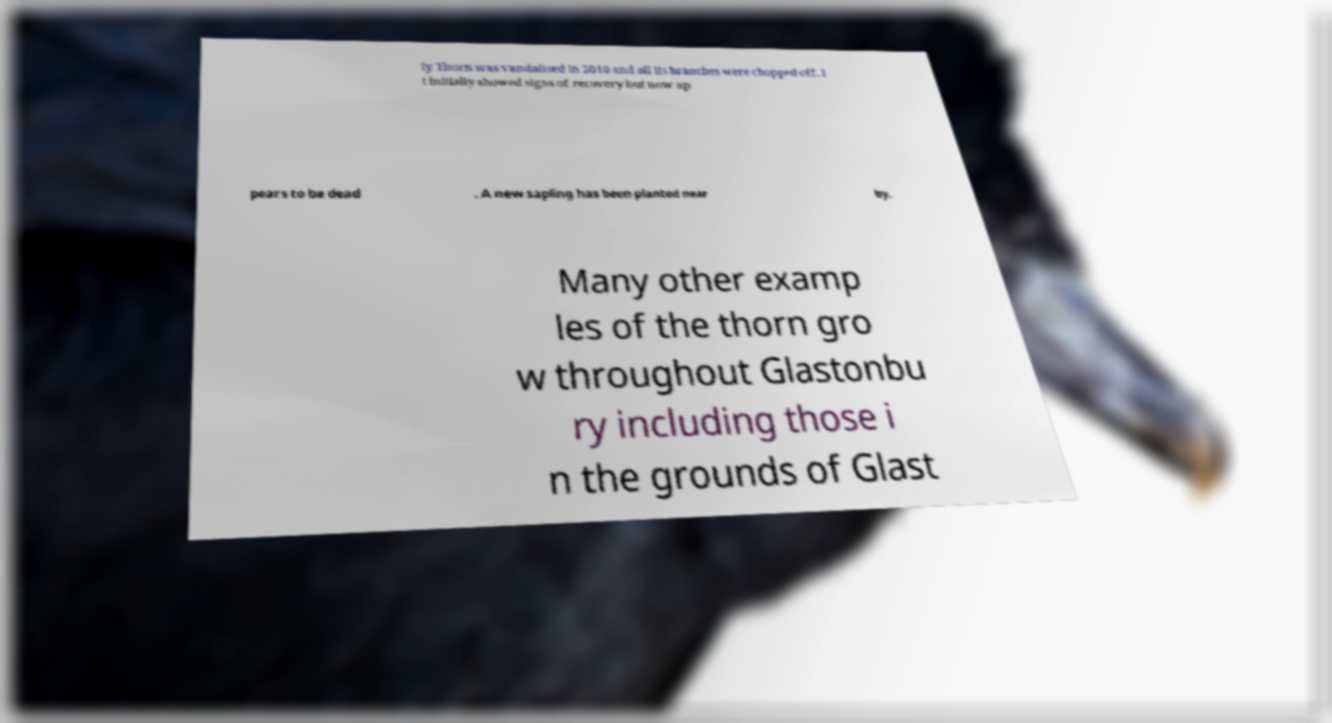Can you accurately transcribe the text from the provided image for me? ly Thorn was vandalised in 2010 and all its branches were chopped off. I t initially showed signs of recovery but now ap pears to be dead . A new sapling has been planted near by. Many other examp les of the thorn gro w throughout Glastonbu ry including those i n the grounds of Glast 